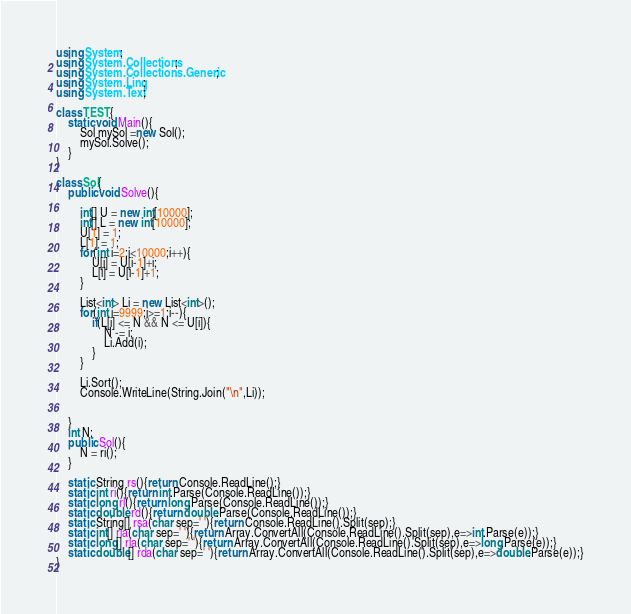Convert code to text. <code><loc_0><loc_0><loc_500><loc_500><_C#_>using System;
using System.Collections;
using System.Collections.Generic;
using System.Linq;
using System.Text;

class TEST{
	static void Main(){
		Sol mySol =new Sol();
		mySol.Solve();
	}
}

class Sol{
	public void Solve(){
		
		int[] U = new int[10000];
		int[] L = new int[10000];
		U[1] = 1;
		L[1] = 1;
		for(int i=2;i<10000;i++){
			U[i] = U[i-1]+i;
			L[i] = U[i-1]+1;
		}
		
		List<int> Li = new List<int>();
		for(int i=9999;i>=1;i--){
			if(L[i] <= N && N <= U[i]){
				N -= i;
				Li.Add(i);
			}
		}
		
		Li.Sort();
		Console.WriteLine(String.Join("\n",Li));
		
		
	}
	int N;
	public Sol(){
		N = ri();
	}

	static String rs(){return Console.ReadLine();}
	static int ri(){return int.Parse(Console.ReadLine());}
	static long rl(){return long.Parse(Console.ReadLine());}
	static double rd(){return double.Parse(Console.ReadLine());}
	static String[] rsa(char sep=' '){return Console.ReadLine().Split(sep);}
	static int[] ria(char sep=' '){return Array.ConvertAll(Console.ReadLine().Split(sep),e=>int.Parse(e));}
	static long[] rla(char sep=' '){return Array.ConvertAll(Console.ReadLine().Split(sep),e=>long.Parse(e));}
	static double[] rda(char sep=' '){return Array.ConvertAll(Console.ReadLine().Split(sep),e=>double.Parse(e));}
}
</code> 